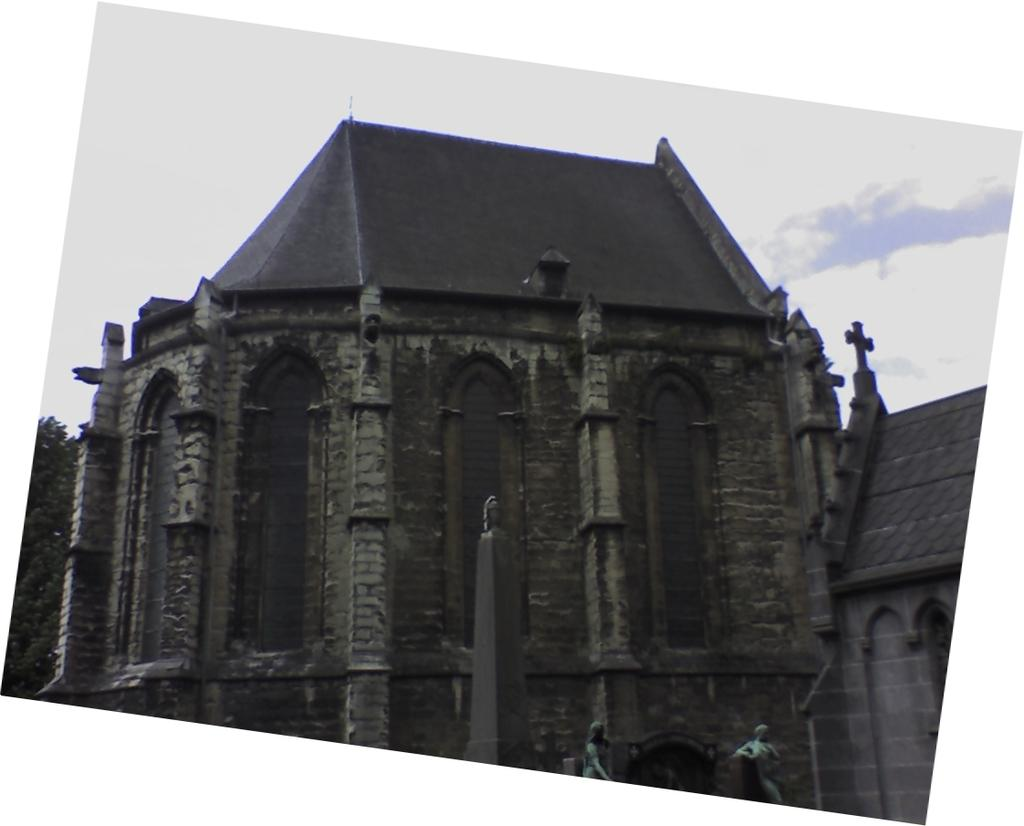What type of structure is visible in the image? There is a building in the image. What type of vegetation is present in the image? There is a tree at the leftmost part of the image. Who is the writer sitting on the sidewalk in the image? There is no writer or sidewalk present in the image. 